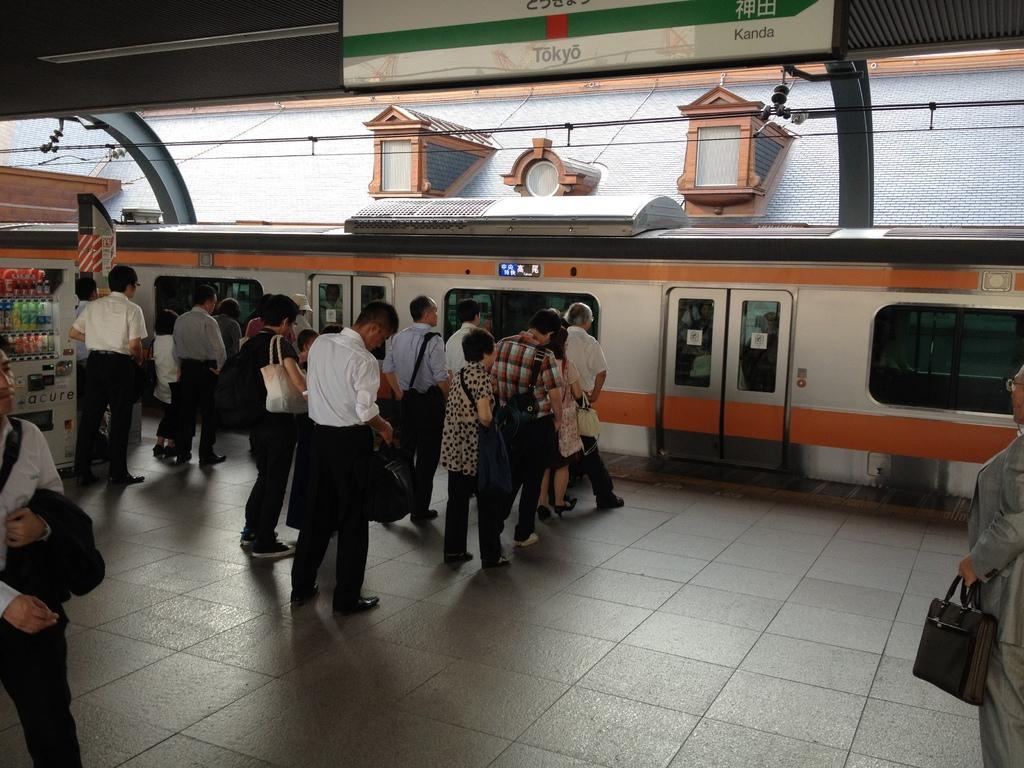Can you describe this image briefly? In this image there is a train on the tracks beside that there are so may people standing on the platform also there is a footstool. 